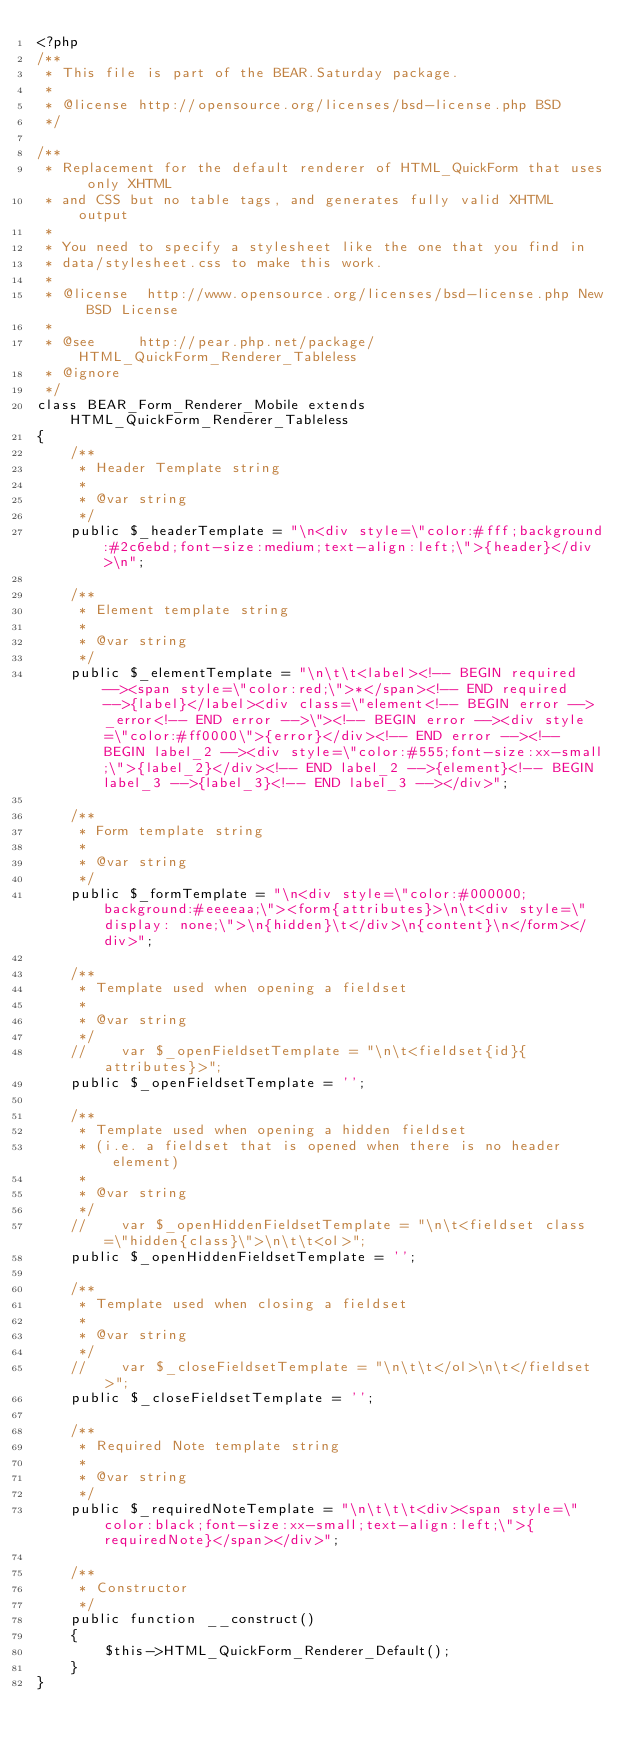Convert code to text. <code><loc_0><loc_0><loc_500><loc_500><_PHP_><?php
/**
 * This file is part of the BEAR.Saturday package.
 *
 * @license http://opensource.org/licenses/bsd-license.php BSD
 */

/**
 * Replacement for the default renderer of HTML_QuickForm that uses only XHTML
 * and CSS but no table tags, and generates fully valid XHTML output
 *
 * You need to specify a stylesheet like the one that you find in
 * data/stylesheet.css to make this work.
 *
 * @license  http://www.opensource.org/licenses/bsd-license.php New BSD License
 *
 * @see     http://pear.php.net/package/HTML_QuickForm_Renderer_Tableless
 * @ignore
 */
class BEAR_Form_Renderer_Mobile extends HTML_QuickForm_Renderer_Tableless
{
    /**
     * Header Template string
     *
     * @var string
     */
    public $_headerTemplate = "\n<div style=\"color:#fff;background:#2c6ebd;font-size:medium;text-align:left;\">{header}</div>\n";

    /**
     * Element template string
     *
     * @var string
     */
    public $_elementTemplate = "\n\t\t<label><!-- BEGIN required --><span style=\"color:red;\">*</span><!-- END required -->{label}</label><div class=\"element<!-- BEGIN error -->_error<!-- END error -->\"><!-- BEGIN error --><div style=\"color:#ff0000\">{error}</div><!-- END error --><!-- BEGIN label_2 --><div style=\"color:#555;font-size:xx-small;\">{label_2}</div><!-- END label_2 -->{element}<!-- BEGIN label_3 -->{label_3}<!-- END label_3 --></div>";

    /**
     * Form template string
     *
     * @var string
     */
    public $_formTemplate = "\n<div style=\"color:#000000;background:#eeeeaa;\"><form{attributes}>\n\t<div style=\"display: none;\">\n{hidden}\t</div>\n{content}\n</form></div>";

    /**
     * Template used when opening a fieldset
     *
     * @var string
     */
    //    var $_openFieldsetTemplate = "\n\t<fieldset{id}{attributes}>";
    public $_openFieldsetTemplate = '';

    /**
     * Template used when opening a hidden fieldset
     * (i.e. a fieldset that is opened when there is no header element)
     *
     * @var string
     */
    //    var $_openHiddenFieldsetTemplate = "\n\t<fieldset class=\"hidden{class}\">\n\t\t<ol>";
    public $_openHiddenFieldsetTemplate = '';

    /**
     * Template used when closing a fieldset
     *
     * @var string
     */
    //    var $_closeFieldsetTemplate = "\n\t\t</ol>\n\t</fieldset>";
    public $_closeFieldsetTemplate = '';

    /**
     * Required Note template string
     *
     * @var string
     */
    public $_requiredNoteTemplate = "\n\t\t\t<div><span style=\"color:black;font-size:xx-small;text-align:left;\">{requiredNote}</span></div>";

    /**
     * Constructor
     */
    public function __construct()
    {
        $this->HTML_QuickForm_Renderer_Default();
    }
}
</code> 